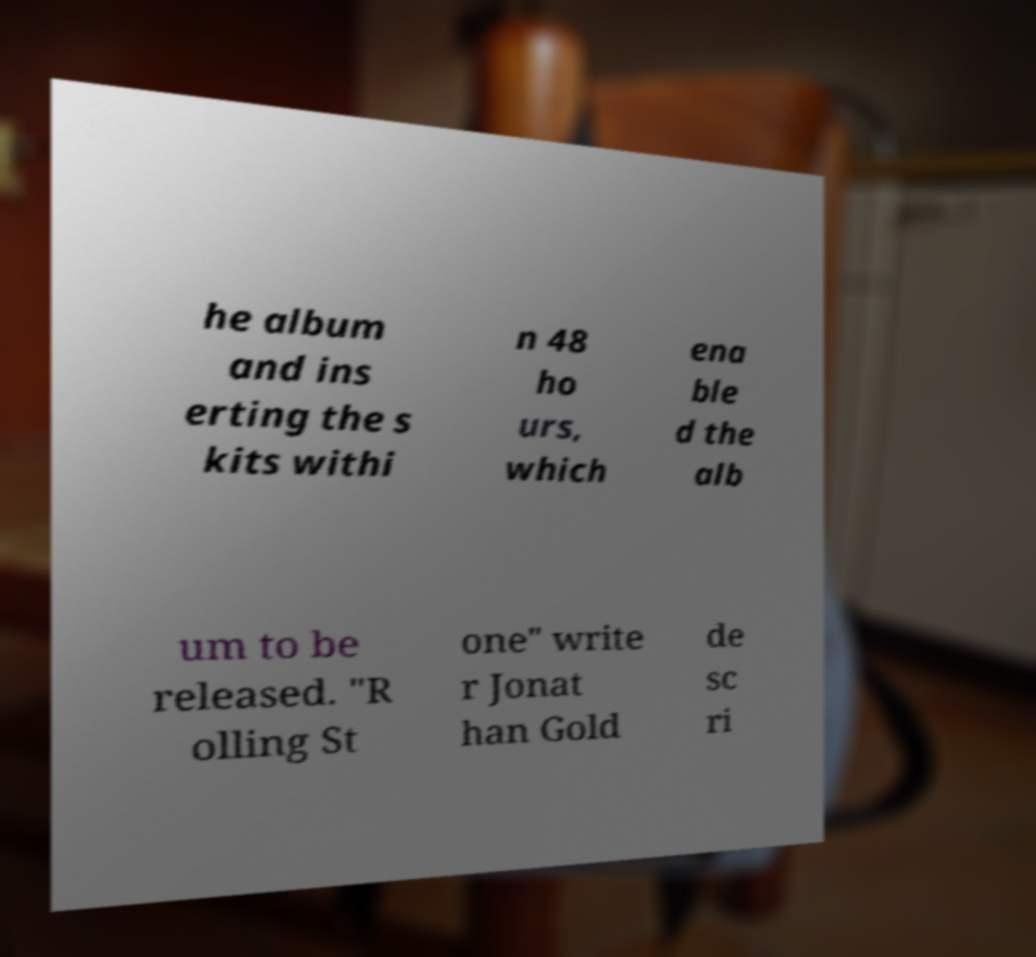Could you assist in decoding the text presented in this image and type it out clearly? he album and ins erting the s kits withi n 48 ho urs, which ena ble d the alb um to be released. "R olling St one" write r Jonat han Gold de sc ri 